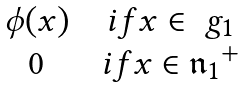Convert formula to latex. <formula><loc_0><loc_0><loc_500><loc_500>\begin{matrix} \phi ( x ) & & i f x \in \ g _ { 1 } \\ 0 & & i f x \in { \mathfrak { n } _ { 1 } } ^ { + } \end{matrix}</formula> 